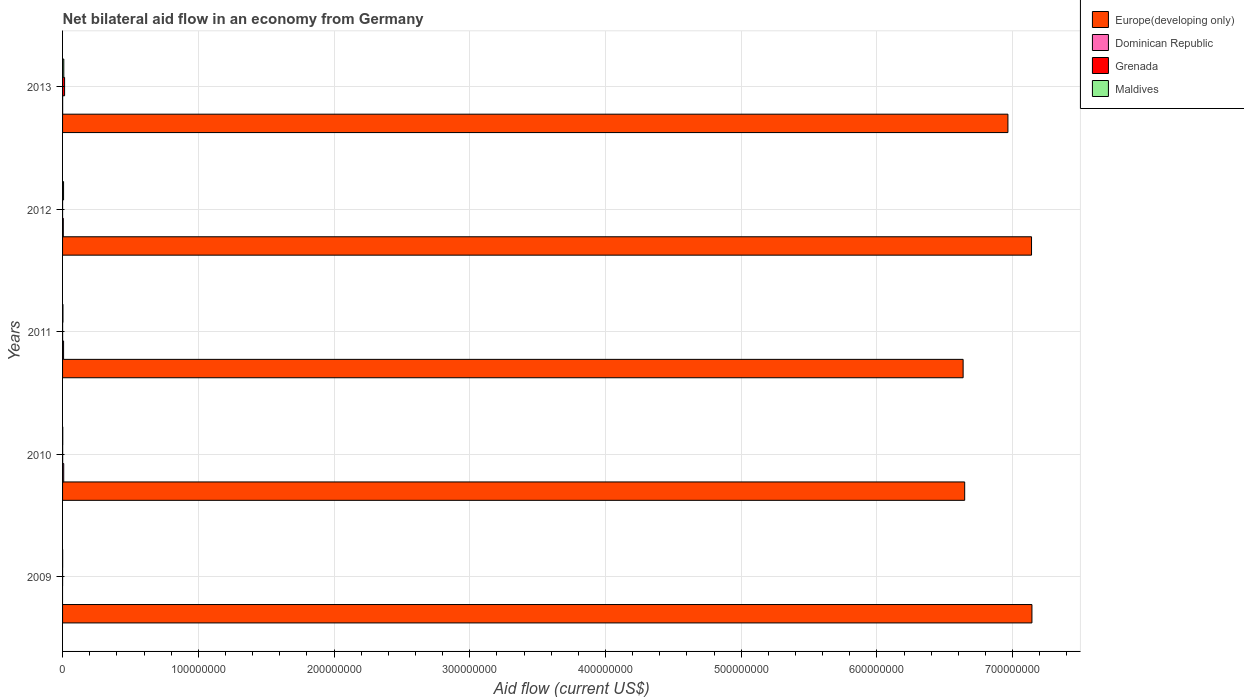How many different coloured bars are there?
Give a very brief answer. 4. Are the number of bars per tick equal to the number of legend labels?
Provide a short and direct response. No. How many bars are there on the 3rd tick from the bottom?
Your response must be concise. 4. What is the label of the 4th group of bars from the top?
Your response must be concise. 2010. What is the net bilateral aid flow in Europe(developing only) in 2010?
Provide a succinct answer. 6.65e+08. Across all years, what is the maximum net bilateral aid flow in Maldives?
Your response must be concise. 9.10e+05. Across all years, what is the minimum net bilateral aid flow in Europe(developing only)?
Your answer should be very brief. 6.64e+08. What is the total net bilateral aid flow in Europe(developing only) in the graph?
Your answer should be very brief. 3.45e+09. What is the difference between the net bilateral aid flow in Grenada in 2010 and that in 2011?
Provide a succinct answer. 4.00e+04. What is the difference between the net bilateral aid flow in Europe(developing only) in 2011 and the net bilateral aid flow in Dominican Republic in 2013?
Offer a very short reply. 6.63e+08. What is the average net bilateral aid flow in Europe(developing only) per year?
Make the answer very short. 6.91e+08. In the year 2013, what is the difference between the net bilateral aid flow in Europe(developing only) and net bilateral aid flow in Grenada?
Provide a succinct answer. 6.95e+08. In how many years, is the net bilateral aid flow in Europe(developing only) greater than 460000000 US$?
Provide a succinct answer. 5. What is the ratio of the net bilateral aid flow in Maldives in 2011 to that in 2012?
Ensure brevity in your answer.  0.38. What is the difference between the highest and the second highest net bilateral aid flow in Dominican Republic?
Your response must be concise. 1.00e+05. What is the difference between the highest and the lowest net bilateral aid flow in Grenada?
Offer a very short reply. 1.48e+06. In how many years, is the net bilateral aid flow in Europe(developing only) greater than the average net bilateral aid flow in Europe(developing only) taken over all years?
Offer a very short reply. 3. Is the sum of the net bilateral aid flow in Europe(developing only) in 2009 and 2010 greater than the maximum net bilateral aid flow in Maldives across all years?
Ensure brevity in your answer.  Yes. Is it the case that in every year, the sum of the net bilateral aid flow in Dominican Republic and net bilateral aid flow in Europe(developing only) is greater than the sum of net bilateral aid flow in Grenada and net bilateral aid flow in Maldives?
Offer a terse response. Yes. Does the graph contain grids?
Keep it short and to the point. Yes. How many legend labels are there?
Keep it short and to the point. 4. How are the legend labels stacked?
Your response must be concise. Vertical. What is the title of the graph?
Your answer should be compact. Net bilateral aid flow in an economy from Germany. Does "Slovak Republic" appear as one of the legend labels in the graph?
Offer a very short reply. No. What is the label or title of the X-axis?
Give a very brief answer. Aid flow (current US$). What is the label or title of the Y-axis?
Provide a short and direct response. Years. What is the Aid flow (current US$) of Europe(developing only) in 2009?
Make the answer very short. 7.14e+08. What is the Aid flow (current US$) of Dominican Republic in 2009?
Ensure brevity in your answer.  0. What is the Aid flow (current US$) in Grenada in 2009?
Keep it short and to the point. 10000. What is the Aid flow (current US$) of Europe(developing only) in 2010?
Give a very brief answer. 6.65e+08. What is the Aid flow (current US$) of Dominican Republic in 2010?
Give a very brief answer. 8.50e+05. What is the Aid flow (current US$) of Grenada in 2010?
Give a very brief answer. 7.00e+04. What is the Aid flow (current US$) in Europe(developing only) in 2011?
Your response must be concise. 6.64e+08. What is the Aid flow (current US$) of Dominican Republic in 2011?
Keep it short and to the point. 7.50e+05. What is the Aid flow (current US$) in Europe(developing only) in 2012?
Offer a terse response. 7.14e+08. What is the Aid flow (current US$) in Dominican Republic in 2012?
Provide a short and direct response. 5.50e+05. What is the Aid flow (current US$) of Maldives in 2012?
Offer a terse response. 7.40e+05. What is the Aid flow (current US$) of Europe(developing only) in 2013?
Your answer should be compact. 6.97e+08. What is the Aid flow (current US$) of Grenada in 2013?
Provide a succinct answer. 1.49e+06. What is the Aid flow (current US$) of Maldives in 2013?
Ensure brevity in your answer.  9.10e+05. Across all years, what is the maximum Aid flow (current US$) of Europe(developing only)?
Give a very brief answer. 7.14e+08. Across all years, what is the maximum Aid flow (current US$) in Dominican Republic?
Your answer should be very brief. 8.50e+05. Across all years, what is the maximum Aid flow (current US$) of Grenada?
Offer a terse response. 1.49e+06. Across all years, what is the maximum Aid flow (current US$) of Maldives?
Offer a terse response. 9.10e+05. Across all years, what is the minimum Aid flow (current US$) of Europe(developing only)?
Provide a succinct answer. 6.64e+08. Across all years, what is the minimum Aid flow (current US$) of Dominican Republic?
Keep it short and to the point. 0. Across all years, what is the minimum Aid flow (current US$) in Grenada?
Provide a short and direct response. 10000. What is the total Aid flow (current US$) in Europe(developing only) in the graph?
Your response must be concise. 3.45e+09. What is the total Aid flow (current US$) of Dominican Republic in the graph?
Provide a succinct answer. 2.21e+06. What is the total Aid flow (current US$) of Grenada in the graph?
Your answer should be compact. 1.61e+06. What is the total Aid flow (current US$) in Maldives in the graph?
Your answer should be compact. 2.12e+06. What is the difference between the Aid flow (current US$) of Europe(developing only) in 2009 and that in 2010?
Provide a short and direct response. 4.96e+07. What is the difference between the Aid flow (current US$) in Grenada in 2009 and that in 2010?
Your answer should be very brief. -6.00e+04. What is the difference between the Aid flow (current US$) of Europe(developing only) in 2009 and that in 2011?
Make the answer very short. 5.07e+07. What is the difference between the Aid flow (current US$) in Grenada in 2009 and that in 2011?
Ensure brevity in your answer.  -2.00e+04. What is the difference between the Aid flow (current US$) of Europe(developing only) in 2009 and that in 2012?
Offer a very short reply. 3.00e+05. What is the difference between the Aid flow (current US$) in Grenada in 2009 and that in 2012?
Ensure brevity in your answer.  0. What is the difference between the Aid flow (current US$) of Maldives in 2009 and that in 2012?
Provide a succinct answer. -6.90e+05. What is the difference between the Aid flow (current US$) of Europe(developing only) in 2009 and that in 2013?
Keep it short and to the point. 1.77e+07. What is the difference between the Aid flow (current US$) in Grenada in 2009 and that in 2013?
Offer a terse response. -1.48e+06. What is the difference between the Aid flow (current US$) in Maldives in 2009 and that in 2013?
Make the answer very short. -8.60e+05. What is the difference between the Aid flow (current US$) of Europe(developing only) in 2010 and that in 2011?
Your answer should be compact. 1.15e+06. What is the difference between the Aid flow (current US$) of Dominican Republic in 2010 and that in 2011?
Make the answer very short. 1.00e+05. What is the difference between the Aid flow (current US$) in Maldives in 2010 and that in 2011?
Make the answer very short. -1.40e+05. What is the difference between the Aid flow (current US$) in Europe(developing only) in 2010 and that in 2012?
Provide a short and direct response. -4.93e+07. What is the difference between the Aid flow (current US$) of Grenada in 2010 and that in 2012?
Your response must be concise. 6.00e+04. What is the difference between the Aid flow (current US$) of Maldives in 2010 and that in 2012?
Provide a succinct answer. -6.00e+05. What is the difference between the Aid flow (current US$) of Europe(developing only) in 2010 and that in 2013?
Provide a succinct answer. -3.19e+07. What is the difference between the Aid flow (current US$) of Dominican Republic in 2010 and that in 2013?
Your response must be concise. 7.90e+05. What is the difference between the Aid flow (current US$) of Grenada in 2010 and that in 2013?
Give a very brief answer. -1.42e+06. What is the difference between the Aid flow (current US$) of Maldives in 2010 and that in 2013?
Your answer should be compact. -7.70e+05. What is the difference between the Aid flow (current US$) in Europe(developing only) in 2011 and that in 2012?
Keep it short and to the point. -5.04e+07. What is the difference between the Aid flow (current US$) in Dominican Republic in 2011 and that in 2012?
Make the answer very short. 2.00e+05. What is the difference between the Aid flow (current US$) of Maldives in 2011 and that in 2012?
Provide a succinct answer. -4.60e+05. What is the difference between the Aid flow (current US$) in Europe(developing only) in 2011 and that in 2013?
Your answer should be compact. -3.30e+07. What is the difference between the Aid flow (current US$) of Dominican Republic in 2011 and that in 2013?
Offer a terse response. 6.90e+05. What is the difference between the Aid flow (current US$) in Grenada in 2011 and that in 2013?
Give a very brief answer. -1.46e+06. What is the difference between the Aid flow (current US$) in Maldives in 2011 and that in 2013?
Ensure brevity in your answer.  -6.30e+05. What is the difference between the Aid flow (current US$) of Europe(developing only) in 2012 and that in 2013?
Ensure brevity in your answer.  1.74e+07. What is the difference between the Aid flow (current US$) of Dominican Republic in 2012 and that in 2013?
Your answer should be compact. 4.90e+05. What is the difference between the Aid flow (current US$) of Grenada in 2012 and that in 2013?
Your answer should be compact. -1.48e+06. What is the difference between the Aid flow (current US$) of Maldives in 2012 and that in 2013?
Give a very brief answer. -1.70e+05. What is the difference between the Aid flow (current US$) in Europe(developing only) in 2009 and the Aid flow (current US$) in Dominican Republic in 2010?
Make the answer very short. 7.13e+08. What is the difference between the Aid flow (current US$) of Europe(developing only) in 2009 and the Aid flow (current US$) of Grenada in 2010?
Your response must be concise. 7.14e+08. What is the difference between the Aid flow (current US$) of Europe(developing only) in 2009 and the Aid flow (current US$) of Maldives in 2010?
Provide a short and direct response. 7.14e+08. What is the difference between the Aid flow (current US$) in Europe(developing only) in 2009 and the Aid flow (current US$) in Dominican Republic in 2011?
Keep it short and to the point. 7.14e+08. What is the difference between the Aid flow (current US$) of Europe(developing only) in 2009 and the Aid flow (current US$) of Grenada in 2011?
Provide a short and direct response. 7.14e+08. What is the difference between the Aid flow (current US$) of Europe(developing only) in 2009 and the Aid flow (current US$) of Maldives in 2011?
Your answer should be compact. 7.14e+08. What is the difference between the Aid flow (current US$) in Europe(developing only) in 2009 and the Aid flow (current US$) in Dominican Republic in 2012?
Make the answer very short. 7.14e+08. What is the difference between the Aid flow (current US$) in Europe(developing only) in 2009 and the Aid flow (current US$) in Grenada in 2012?
Your answer should be very brief. 7.14e+08. What is the difference between the Aid flow (current US$) in Europe(developing only) in 2009 and the Aid flow (current US$) in Maldives in 2012?
Your response must be concise. 7.14e+08. What is the difference between the Aid flow (current US$) in Grenada in 2009 and the Aid flow (current US$) in Maldives in 2012?
Make the answer very short. -7.30e+05. What is the difference between the Aid flow (current US$) in Europe(developing only) in 2009 and the Aid flow (current US$) in Dominican Republic in 2013?
Give a very brief answer. 7.14e+08. What is the difference between the Aid flow (current US$) of Europe(developing only) in 2009 and the Aid flow (current US$) of Grenada in 2013?
Provide a succinct answer. 7.13e+08. What is the difference between the Aid flow (current US$) in Europe(developing only) in 2009 and the Aid flow (current US$) in Maldives in 2013?
Make the answer very short. 7.13e+08. What is the difference between the Aid flow (current US$) of Grenada in 2009 and the Aid flow (current US$) of Maldives in 2013?
Your answer should be very brief. -9.00e+05. What is the difference between the Aid flow (current US$) of Europe(developing only) in 2010 and the Aid flow (current US$) of Dominican Republic in 2011?
Your response must be concise. 6.64e+08. What is the difference between the Aid flow (current US$) of Europe(developing only) in 2010 and the Aid flow (current US$) of Grenada in 2011?
Ensure brevity in your answer.  6.65e+08. What is the difference between the Aid flow (current US$) of Europe(developing only) in 2010 and the Aid flow (current US$) of Maldives in 2011?
Offer a very short reply. 6.64e+08. What is the difference between the Aid flow (current US$) in Dominican Republic in 2010 and the Aid flow (current US$) in Grenada in 2011?
Your answer should be very brief. 8.20e+05. What is the difference between the Aid flow (current US$) of Dominican Republic in 2010 and the Aid flow (current US$) of Maldives in 2011?
Provide a short and direct response. 5.70e+05. What is the difference between the Aid flow (current US$) of Europe(developing only) in 2010 and the Aid flow (current US$) of Dominican Republic in 2012?
Make the answer very short. 6.64e+08. What is the difference between the Aid flow (current US$) of Europe(developing only) in 2010 and the Aid flow (current US$) of Grenada in 2012?
Offer a very short reply. 6.65e+08. What is the difference between the Aid flow (current US$) in Europe(developing only) in 2010 and the Aid flow (current US$) in Maldives in 2012?
Provide a succinct answer. 6.64e+08. What is the difference between the Aid flow (current US$) of Dominican Republic in 2010 and the Aid flow (current US$) of Grenada in 2012?
Provide a short and direct response. 8.40e+05. What is the difference between the Aid flow (current US$) of Grenada in 2010 and the Aid flow (current US$) of Maldives in 2012?
Your response must be concise. -6.70e+05. What is the difference between the Aid flow (current US$) of Europe(developing only) in 2010 and the Aid flow (current US$) of Dominican Republic in 2013?
Your answer should be compact. 6.65e+08. What is the difference between the Aid flow (current US$) in Europe(developing only) in 2010 and the Aid flow (current US$) in Grenada in 2013?
Provide a succinct answer. 6.63e+08. What is the difference between the Aid flow (current US$) in Europe(developing only) in 2010 and the Aid flow (current US$) in Maldives in 2013?
Offer a terse response. 6.64e+08. What is the difference between the Aid flow (current US$) in Dominican Republic in 2010 and the Aid flow (current US$) in Grenada in 2013?
Offer a terse response. -6.40e+05. What is the difference between the Aid flow (current US$) in Dominican Republic in 2010 and the Aid flow (current US$) in Maldives in 2013?
Your answer should be compact. -6.00e+04. What is the difference between the Aid flow (current US$) of Grenada in 2010 and the Aid flow (current US$) of Maldives in 2013?
Your answer should be very brief. -8.40e+05. What is the difference between the Aid flow (current US$) of Europe(developing only) in 2011 and the Aid flow (current US$) of Dominican Republic in 2012?
Make the answer very short. 6.63e+08. What is the difference between the Aid flow (current US$) in Europe(developing only) in 2011 and the Aid flow (current US$) in Grenada in 2012?
Your response must be concise. 6.64e+08. What is the difference between the Aid flow (current US$) of Europe(developing only) in 2011 and the Aid flow (current US$) of Maldives in 2012?
Offer a very short reply. 6.63e+08. What is the difference between the Aid flow (current US$) in Dominican Republic in 2011 and the Aid flow (current US$) in Grenada in 2012?
Provide a short and direct response. 7.40e+05. What is the difference between the Aid flow (current US$) in Grenada in 2011 and the Aid flow (current US$) in Maldives in 2012?
Your answer should be compact. -7.10e+05. What is the difference between the Aid flow (current US$) of Europe(developing only) in 2011 and the Aid flow (current US$) of Dominican Republic in 2013?
Provide a short and direct response. 6.63e+08. What is the difference between the Aid flow (current US$) of Europe(developing only) in 2011 and the Aid flow (current US$) of Grenada in 2013?
Give a very brief answer. 6.62e+08. What is the difference between the Aid flow (current US$) of Europe(developing only) in 2011 and the Aid flow (current US$) of Maldives in 2013?
Ensure brevity in your answer.  6.63e+08. What is the difference between the Aid flow (current US$) of Dominican Republic in 2011 and the Aid flow (current US$) of Grenada in 2013?
Give a very brief answer. -7.40e+05. What is the difference between the Aid flow (current US$) in Grenada in 2011 and the Aid flow (current US$) in Maldives in 2013?
Your answer should be compact. -8.80e+05. What is the difference between the Aid flow (current US$) in Europe(developing only) in 2012 and the Aid flow (current US$) in Dominican Republic in 2013?
Your answer should be compact. 7.14e+08. What is the difference between the Aid flow (current US$) of Europe(developing only) in 2012 and the Aid flow (current US$) of Grenada in 2013?
Give a very brief answer. 7.12e+08. What is the difference between the Aid flow (current US$) in Europe(developing only) in 2012 and the Aid flow (current US$) in Maldives in 2013?
Make the answer very short. 7.13e+08. What is the difference between the Aid flow (current US$) in Dominican Republic in 2012 and the Aid flow (current US$) in Grenada in 2013?
Offer a very short reply. -9.40e+05. What is the difference between the Aid flow (current US$) in Dominican Republic in 2012 and the Aid flow (current US$) in Maldives in 2013?
Provide a short and direct response. -3.60e+05. What is the difference between the Aid flow (current US$) in Grenada in 2012 and the Aid flow (current US$) in Maldives in 2013?
Your answer should be compact. -9.00e+05. What is the average Aid flow (current US$) in Europe(developing only) per year?
Provide a succinct answer. 6.91e+08. What is the average Aid flow (current US$) of Dominican Republic per year?
Keep it short and to the point. 4.42e+05. What is the average Aid flow (current US$) in Grenada per year?
Your answer should be very brief. 3.22e+05. What is the average Aid flow (current US$) in Maldives per year?
Give a very brief answer. 4.24e+05. In the year 2009, what is the difference between the Aid flow (current US$) of Europe(developing only) and Aid flow (current US$) of Grenada?
Offer a very short reply. 7.14e+08. In the year 2009, what is the difference between the Aid flow (current US$) of Europe(developing only) and Aid flow (current US$) of Maldives?
Make the answer very short. 7.14e+08. In the year 2009, what is the difference between the Aid flow (current US$) of Grenada and Aid flow (current US$) of Maldives?
Keep it short and to the point. -4.00e+04. In the year 2010, what is the difference between the Aid flow (current US$) in Europe(developing only) and Aid flow (current US$) in Dominican Republic?
Your response must be concise. 6.64e+08. In the year 2010, what is the difference between the Aid flow (current US$) of Europe(developing only) and Aid flow (current US$) of Grenada?
Give a very brief answer. 6.65e+08. In the year 2010, what is the difference between the Aid flow (current US$) of Europe(developing only) and Aid flow (current US$) of Maldives?
Offer a very short reply. 6.65e+08. In the year 2010, what is the difference between the Aid flow (current US$) of Dominican Republic and Aid flow (current US$) of Grenada?
Provide a short and direct response. 7.80e+05. In the year 2010, what is the difference between the Aid flow (current US$) in Dominican Republic and Aid flow (current US$) in Maldives?
Give a very brief answer. 7.10e+05. In the year 2011, what is the difference between the Aid flow (current US$) in Europe(developing only) and Aid flow (current US$) in Dominican Republic?
Provide a succinct answer. 6.63e+08. In the year 2011, what is the difference between the Aid flow (current US$) in Europe(developing only) and Aid flow (current US$) in Grenada?
Give a very brief answer. 6.64e+08. In the year 2011, what is the difference between the Aid flow (current US$) in Europe(developing only) and Aid flow (current US$) in Maldives?
Offer a very short reply. 6.63e+08. In the year 2011, what is the difference between the Aid flow (current US$) of Dominican Republic and Aid flow (current US$) of Grenada?
Keep it short and to the point. 7.20e+05. In the year 2011, what is the difference between the Aid flow (current US$) in Grenada and Aid flow (current US$) in Maldives?
Ensure brevity in your answer.  -2.50e+05. In the year 2012, what is the difference between the Aid flow (current US$) in Europe(developing only) and Aid flow (current US$) in Dominican Republic?
Your answer should be very brief. 7.13e+08. In the year 2012, what is the difference between the Aid flow (current US$) in Europe(developing only) and Aid flow (current US$) in Grenada?
Keep it short and to the point. 7.14e+08. In the year 2012, what is the difference between the Aid flow (current US$) of Europe(developing only) and Aid flow (current US$) of Maldives?
Offer a terse response. 7.13e+08. In the year 2012, what is the difference between the Aid flow (current US$) of Dominican Republic and Aid flow (current US$) of Grenada?
Your answer should be compact. 5.40e+05. In the year 2012, what is the difference between the Aid flow (current US$) in Grenada and Aid flow (current US$) in Maldives?
Make the answer very short. -7.30e+05. In the year 2013, what is the difference between the Aid flow (current US$) in Europe(developing only) and Aid flow (current US$) in Dominican Republic?
Your answer should be very brief. 6.96e+08. In the year 2013, what is the difference between the Aid flow (current US$) of Europe(developing only) and Aid flow (current US$) of Grenada?
Ensure brevity in your answer.  6.95e+08. In the year 2013, what is the difference between the Aid flow (current US$) in Europe(developing only) and Aid flow (current US$) in Maldives?
Provide a succinct answer. 6.96e+08. In the year 2013, what is the difference between the Aid flow (current US$) in Dominican Republic and Aid flow (current US$) in Grenada?
Make the answer very short. -1.43e+06. In the year 2013, what is the difference between the Aid flow (current US$) in Dominican Republic and Aid flow (current US$) in Maldives?
Offer a terse response. -8.50e+05. In the year 2013, what is the difference between the Aid flow (current US$) of Grenada and Aid flow (current US$) of Maldives?
Offer a terse response. 5.80e+05. What is the ratio of the Aid flow (current US$) in Europe(developing only) in 2009 to that in 2010?
Offer a very short reply. 1.07. What is the ratio of the Aid flow (current US$) in Grenada in 2009 to that in 2010?
Ensure brevity in your answer.  0.14. What is the ratio of the Aid flow (current US$) in Maldives in 2009 to that in 2010?
Offer a terse response. 0.36. What is the ratio of the Aid flow (current US$) in Europe(developing only) in 2009 to that in 2011?
Your answer should be very brief. 1.08. What is the ratio of the Aid flow (current US$) of Grenada in 2009 to that in 2011?
Ensure brevity in your answer.  0.33. What is the ratio of the Aid flow (current US$) of Maldives in 2009 to that in 2011?
Provide a succinct answer. 0.18. What is the ratio of the Aid flow (current US$) in Europe(developing only) in 2009 to that in 2012?
Ensure brevity in your answer.  1. What is the ratio of the Aid flow (current US$) of Maldives in 2009 to that in 2012?
Keep it short and to the point. 0.07. What is the ratio of the Aid flow (current US$) of Europe(developing only) in 2009 to that in 2013?
Your response must be concise. 1.03. What is the ratio of the Aid flow (current US$) in Grenada in 2009 to that in 2013?
Keep it short and to the point. 0.01. What is the ratio of the Aid flow (current US$) in Maldives in 2009 to that in 2013?
Your answer should be compact. 0.05. What is the ratio of the Aid flow (current US$) in Europe(developing only) in 2010 to that in 2011?
Provide a succinct answer. 1. What is the ratio of the Aid flow (current US$) of Dominican Republic in 2010 to that in 2011?
Your response must be concise. 1.13. What is the ratio of the Aid flow (current US$) in Grenada in 2010 to that in 2011?
Keep it short and to the point. 2.33. What is the ratio of the Aid flow (current US$) of Maldives in 2010 to that in 2011?
Offer a terse response. 0.5. What is the ratio of the Aid flow (current US$) in Europe(developing only) in 2010 to that in 2012?
Your response must be concise. 0.93. What is the ratio of the Aid flow (current US$) of Dominican Republic in 2010 to that in 2012?
Your response must be concise. 1.55. What is the ratio of the Aid flow (current US$) in Grenada in 2010 to that in 2012?
Give a very brief answer. 7. What is the ratio of the Aid flow (current US$) in Maldives in 2010 to that in 2012?
Your answer should be compact. 0.19. What is the ratio of the Aid flow (current US$) of Europe(developing only) in 2010 to that in 2013?
Offer a very short reply. 0.95. What is the ratio of the Aid flow (current US$) in Dominican Republic in 2010 to that in 2013?
Offer a very short reply. 14.17. What is the ratio of the Aid flow (current US$) of Grenada in 2010 to that in 2013?
Your answer should be compact. 0.05. What is the ratio of the Aid flow (current US$) in Maldives in 2010 to that in 2013?
Your answer should be compact. 0.15. What is the ratio of the Aid flow (current US$) of Europe(developing only) in 2011 to that in 2012?
Provide a succinct answer. 0.93. What is the ratio of the Aid flow (current US$) in Dominican Republic in 2011 to that in 2012?
Your answer should be very brief. 1.36. What is the ratio of the Aid flow (current US$) of Grenada in 2011 to that in 2012?
Ensure brevity in your answer.  3. What is the ratio of the Aid flow (current US$) of Maldives in 2011 to that in 2012?
Your answer should be very brief. 0.38. What is the ratio of the Aid flow (current US$) in Europe(developing only) in 2011 to that in 2013?
Give a very brief answer. 0.95. What is the ratio of the Aid flow (current US$) of Dominican Republic in 2011 to that in 2013?
Your answer should be very brief. 12.5. What is the ratio of the Aid flow (current US$) of Grenada in 2011 to that in 2013?
Make the answer very short. 0.02. What is the ratio of the Aid flow (current US$) in Maldives in 2011 to that in 2013?
Your answer should be compact. 0.31. What is the ratio of the Aid flow (current US$) in Dominican Republic in 2012 to that in 2013?
Provide a short and direct response. 9.17. What is the ratio of the Aid flow (current US$) of Grenada in 2012 to that in 2013?
Your answer should be compact. 0.01. What is the ratio of the Aid flow (current US$) of Maldives in 2012 to that in 2013?
Provide a short and direct response. 0.81. What is the difference between the highest and the second highest Aid flow (current US$) in Grenada?
Keep it short and to the point. 1.42e+06. What is the difference between the highest and the lowest Aid flow (current US$) of Europe(developing only)?
Provide a succinct answer. 5.07e+07. What is the difference between the highest and the lowest Aid flow (current US$) of Dominican Republic?
Provide a succinct answer. 8.50e+05. What is the difference between the highest and the lowest Aid flow (current US$) in Grenada?
Keep it short and to the point. 1.48e+06. What is the difference between the highest and the lowest Aid flow (current US$) in Maldives?
Provide a short and direct response. 8.60e+05. 